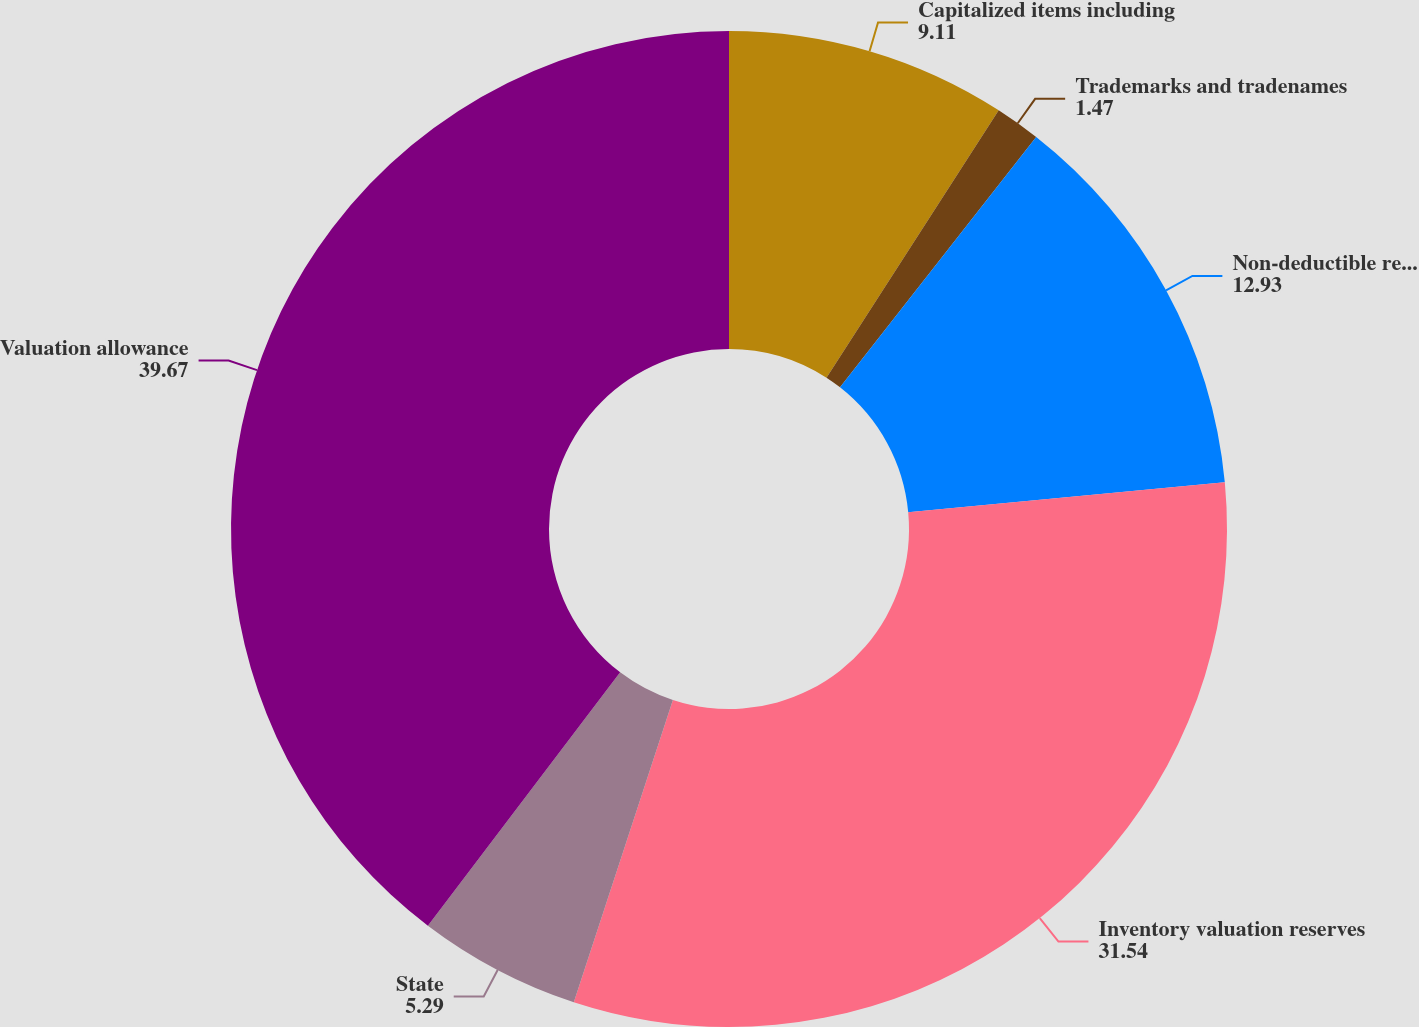<chart> <loc_0><loc_0><loc_500><loc_500><pie_chart><fcel>Capitalized items including<fcel>Trademarks and tradenames<fcel>Non-deductible reserves and<fcel>Inventory valuation reserves<fcel>State<fcel>Valuation allowance<nl><fcel>9.11%<fcel>1.47%<fcel>12.93%<fcel>31.54%<fcel>5.29%<fcel>39.67%<nl></chart> 